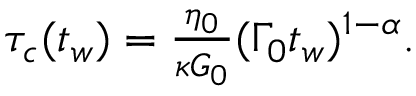<formula> <loc_0><loc_0><loc_500><loc_500>\begin{array} { r } { \tau _ { c } ( t _ { w } ) = \frac { \eta _ { 0 } } { \kappa G _ { 0 } } ( \Gamma _ { 0 } t _ { w } ) ^ { 1 - \alpha } . } \end{array}</formula> 